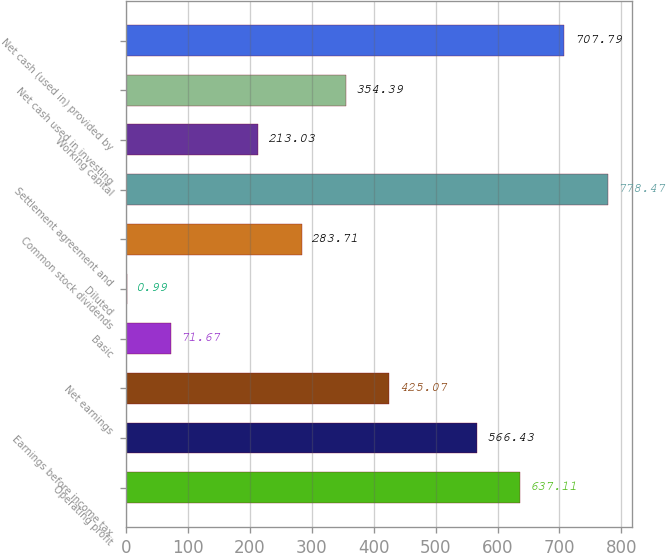Convert chart. <chart><loc_0><loc_0><loc_500><loc_500><bar_chart><fcel>Operating profit<fcel>Earnings before income tax<fcel>Net earnings<fcel>Basic<fcel>Diluted<fcel>Common stock dividends<fcel>Settlement agreement and<fcel>Working capital<fcel>Net cash used in investing<fcel>Net cash (used in) provided by<nl><fcel>637.11<fcel>566.43<fcel>425.07<fcel>71.67<fcel>0.99<fcel>283.71<fcel>778.47<fcel>213.03<fcel>354.39<fcel>707.79<nl></chart> 